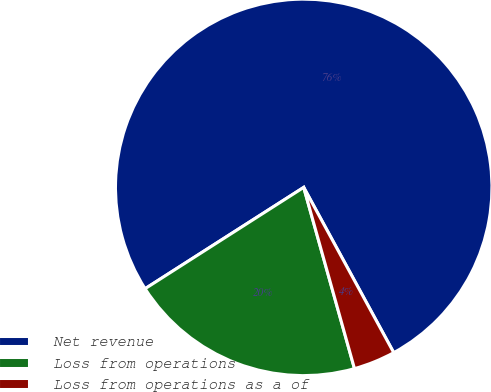Convert chart to OTSL. <chart><loc_0><loc_0><loc_500><loc_500><pie_chart><fcel>Net revenue<fcel>Loss from operations<fcel>Loss from operations as a of<nl><fcel>76.11%<fcel>20.3%<fcel>3.59%<nl></chart> 